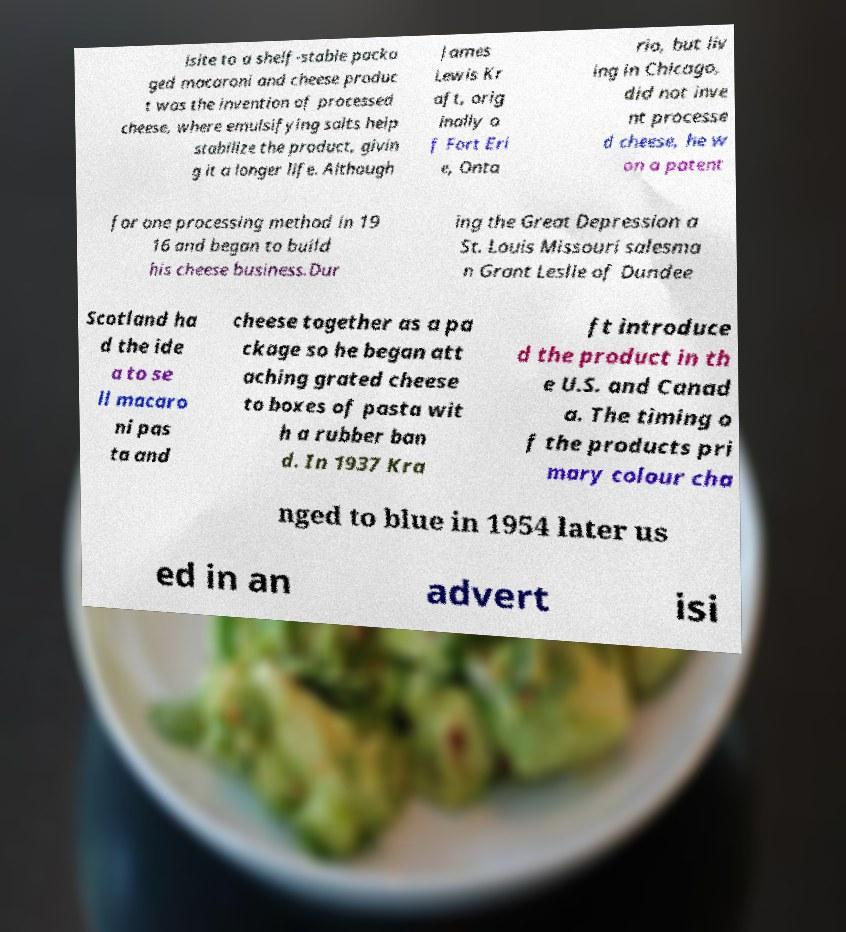Could you extract and type out the text from this image? isite to a shelf-stable packa ged macaroni and cheese produc t was the invention of processed cheese, where emulsifying salts help stabilize the product, givin g it a longer life. Although James Lewis Kr aft, orig inally o f Fort Eri e, Onta rio, but liv ing in Chicago, did not inve nt processe d cheese, he w on a patent for one processing method in 19 16 and began to build his cheese business.Dur ing the Great Depression a St. Louis Missouri salesma n Grant Leslie of Dundee Scotland ha d the ide a to se ll macaro ni pas ta and cheese together as a pa ckage so he began att aching grated cheese to boxes of pasta wit h a rubber ban d. In 1937 Kra ft introduce d the product in th e U.S. and Canad a. The timing o f the products pri mary colour cha nged to blue in 1954 later us ed in an advert isi 